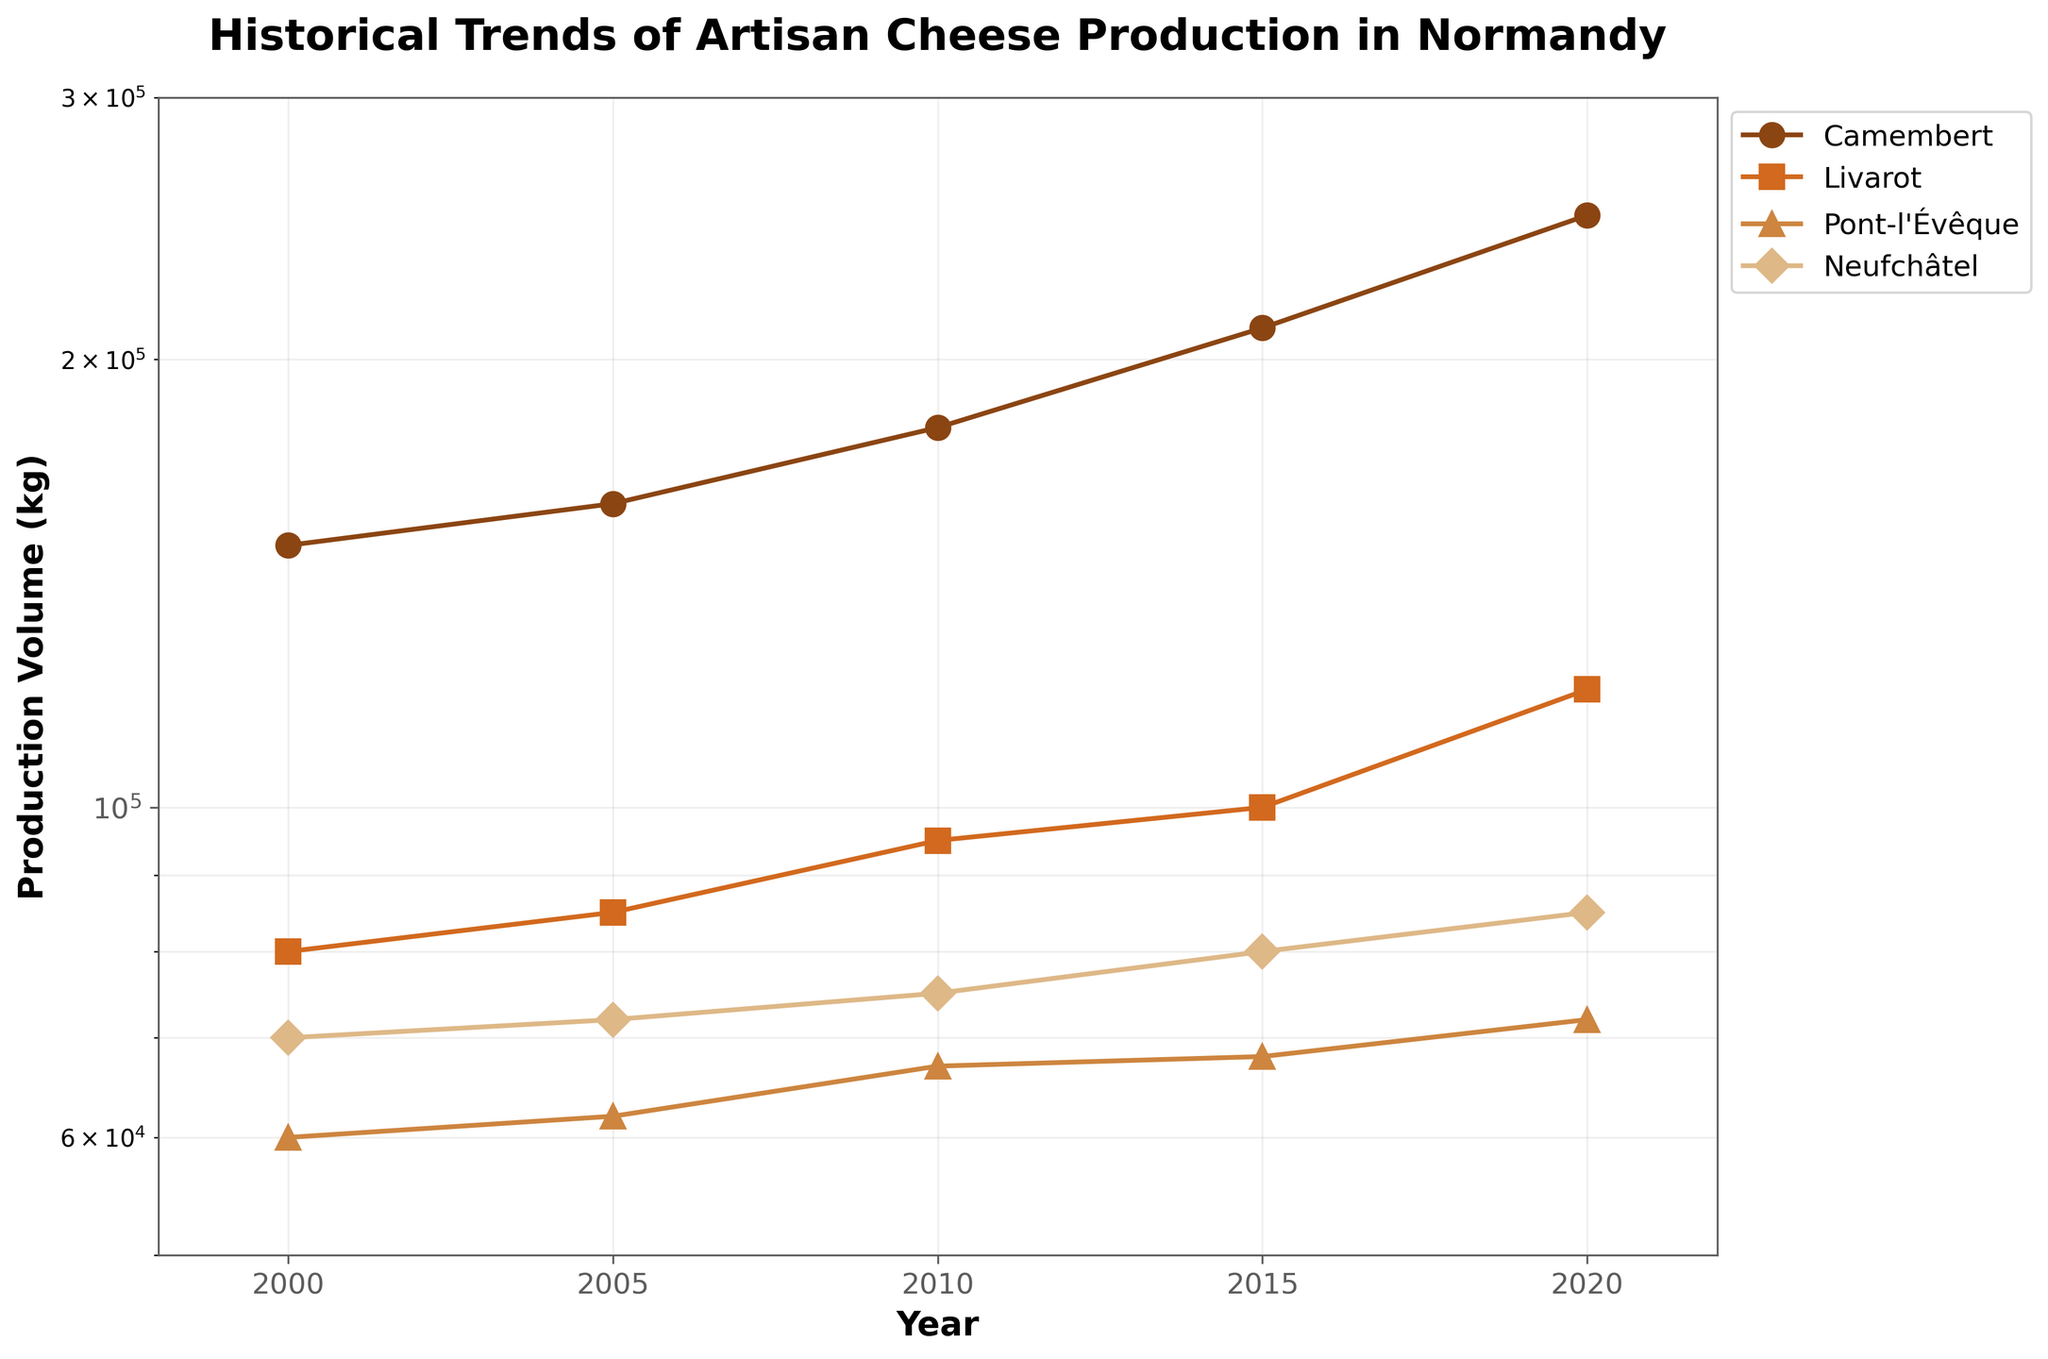What is the title of the figure? The title of the figure is typically located at the top of the plot and provides a brief description of the content displayed. Here, it reads "Historical Trends of Artisan Cheese Production in Normandy," which sets the context for the viewer.
Answer: Historical Trends of Artisan Cheese Production in Normandy Which region had the highest production volume in 2020? To determine which region had the highest production volume in 2020, locate the data points for the year 2020 on the x-axis and find the highest y-axis value among them. The plot uses a log scale, but the highest production volume still corresponds to "Camembert."
Answer: Camembert How did Livarot's production volume change from 2000 to 2020? To understand Livarot’s production change, look at the data points for Livarot in 2000 and 2020. The production increased from 80,000 kg to 120,000 kg. The change is 120,000 - 80,000 = 40,000 kg.
Answer: Increased by 40,000 kg Which region showed the least growth in production volume from 2000 to 2020? To identify the region with the least growth, calculate the difference in production volume between 2000 and 2020 for each region. Pont-l'Évêque grew from 60,000 kg to 72,000 kg, which is an increase of only 12,000 kg, the smallest increase among the regions.
Answer: Pont-l'Évêque In which years did Camembert show a production volume above 200,000 kg? To answer this, scan the y-axis values for Camembert, which are plotted on a log scale. Camembert's production volume was above 200,000 kg in 2015 and 2020.
Answer: 2015 and 2020 Compare the production volumes of Neufchâtel and Pont-l'Évêque in 2010. Which one was higher? Look at the data points for 2010 for both Neufchâtel and Pont-l'Évêque. Neufchâtel's production was 75,000 kg, while Pont-l'Évêque's was 67,000 kg. Therefore, Neufchâtel had the higher production volume.
Answer: Neufchâtel What was the average production volume for Camembert between 2000 and 2020? Sum up the production volumes for Camembert across the years (150,000 kg, 160,000 kg, 180,000 kg, 210,000 kg, 250,000 kg) which totals 950,000 kg. Divide by 5 (the number of data points), resulting in an average of 190,000 kg.
Answer: 190,000 kg Which region had the smallest production volume in 2000? Refer to the y-axis values for 2000 to identify the region. Pont-l'Évêque had the smallest production volume at 60,000 kg.
Answer: Pont-l'Évêque How does the log scale affect the perception of changes in the production volume data? A log scale compresses large ranges into a more manageable span, making it easier to compare growth rates across very different values. It visually shows exponential growth as linear, emphasizing relative rather than absolute changes. This can make smaller changes appear more significant.
Answer: Emphasizes relative changes, making smaller changes appear significant 